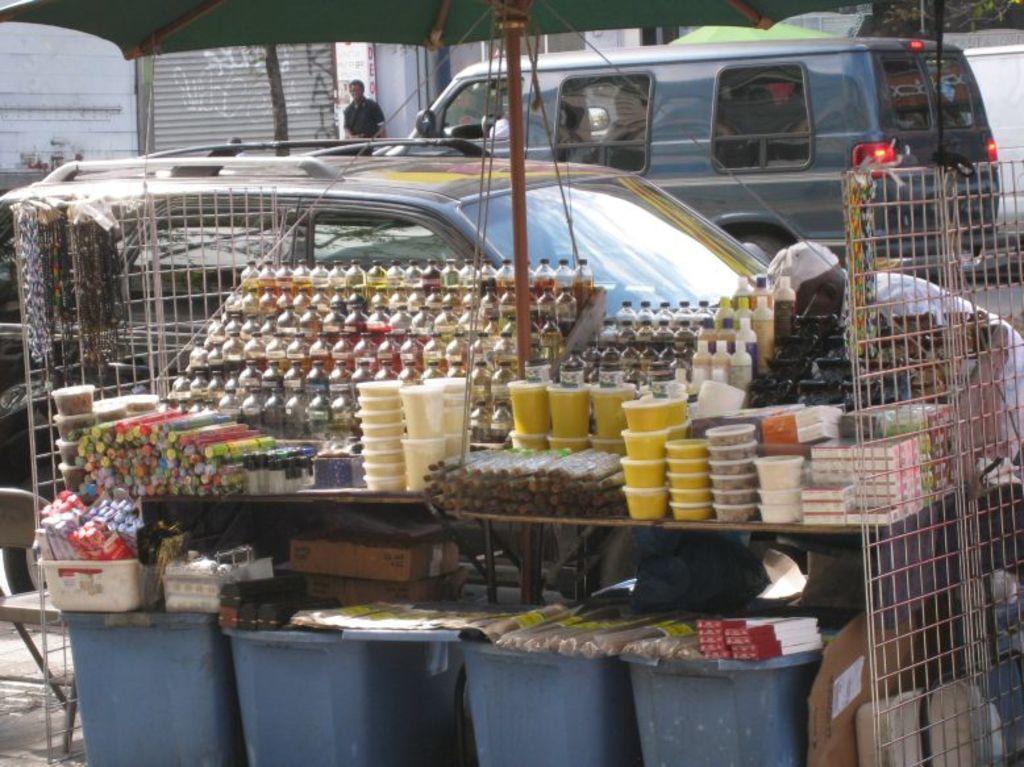Describe this image in one or two sentences. In this image there is a table. There are boxes and bottles on the table. Below the table there are buckets. There are packets on the buckets. Above the table there is a table umbrella. Behind the table there are vehicles moving. In the background there are buildings. There is person near the building. 